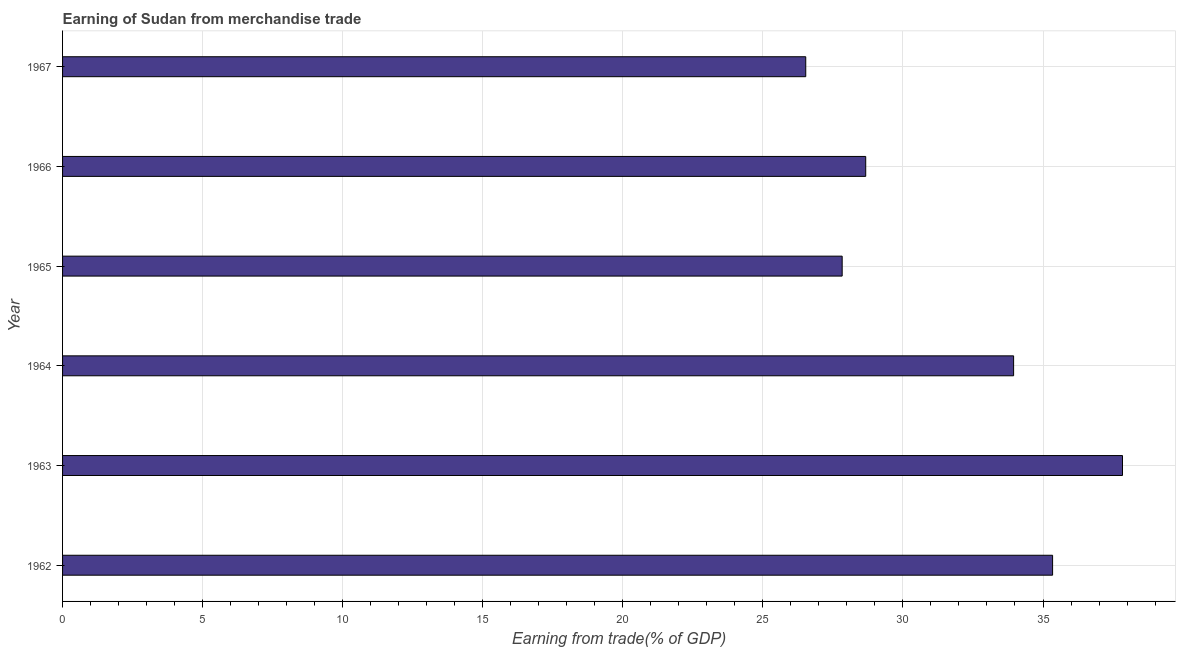What is the title of the graph?
Your answer should be compact. Earning of Sudan from merchandise trade. What is the label or title of the X-axis?
Offer a very short reply. Earning from trade(% of GDP). What is the earning from merchandise trade in 1963?
Give a very brief answer. 37.84. Across all years, what is the maximum earning from merchandise trade?
Make the answer very short. 37.84. Across all years, what is the minimum earning from merchandise trade?
Your answer should be compact. 26.53. In which year was the earning from merchandise trade minimum?
Ensure brevity in your answer.  1967. What is the sum of the earning from merchandise trade?
Ensure brevity in your answer.  190.17. What is the difference between the earning from merchandise trade in 1963 and 1965?
Keep it short and to the point. 10.01. What is the average earning from merchandise trade per year?
Your response must be concise. 31.69. What is the median earning from merchandise trade?
Offer a very short reply. 31.31. In how many years, is the earning from merchandise trade greater than 18 %?
Provide a succinct answer. 6. Do a majority of the years between 1964 and 1962 (inclusive) have earning from merchandise trade greater than 32 %?
Keep it short and to the point. Yes. What is the ratio of the earning from merchandise trade in 1965 to that in 1967?
Provide a succinct answer. 1.05. Is the earning from merchandise trade in 1965 less than that in 1966?
Offer a very short reply. Yes. Is the difference between the earning from merchandise trade in 1964 and 1967 greater than the difference between any two years?
Make the answer very short. No. What is the difference between the highest and the second highest earning from merchandise trade?
Ensure brevity in your answer.  2.5. Is the sum of the earning from merchandise trade in 1964 and 1965 greater than the maximum earning from merchandise trade across all years?
Keep it short and to the point. Yes. What is the difference between the highest and the lowest earning from merchandise trade?
Provide a succinct answer. 11.31. In how many years, is the earning from merchandise trade greater than the average earning from merchandise trade taken over all years?
Give a very brief answer. 3. What is the difference between two consecutive major ticks on the X-axis?
Make the answer very short. 5. What is the Earning from trade(% of GDP) of 1962?
Your answer should be very brief. 35.34. What is the Earning from trade(% of GDP) in 1963?
Give a very brief answer. 37.84. What is the Earning from trade(% of GDP) in 1964?
Your response must be concise. 33.95. What is the Earning from trade(% of GDP) of 1965?
Make the answer very short. 27.83. What is the Earning from trade(% of GDP) of 1966?
Your answer should be very brief. 28.67. What is the Earning from trade(% of GDP) of 1967?
Keep it short and to the point. 26.53. What is the difference between the Earning from trade(% of GDP) in 1962 and 1963?
Ensure brevity in your answer.  -2.5. What is the difference between the Earning from trade(% of GDP) in 1962 and 1964?
Your response must be concise. 1.39. What is the difference between the Earning from trade(% of GDP) in 1962 and 1965?
Provide a succinct answer. 7.51. What is the difference between the Earning from trade(% of GDP) in 1962 and 1966?
Your response must be concise. 6.67. What is the difference between the Earning from trade(% of GDP) in 1962 and 1967?
Provide a succinct answer. 8.81. What is the difference between the Earning from trade(% of GDP) in 1963 and 1964?
Offer a terse response. 3.89. What is the difference between the Earning from trade(% of GDP) in 1963 and 1965?
Your response must be concise. 10.01. What is the difference between the Earning from trade(% of GDP) in 1963 and 1966?
Give a very brief answer. 9.17. What is the difference between the Earning from trade(% of GDP) in 1963 and 1967?
Give a very brief answer. 11.31. What is the difference between the Earning from trade(% of GDP) in 1964 and 1965?
Your answer should be very brief. 6.12. What is the difference between the Earning from trade(% of GDP) in 1964 and 1966?
Your response must be concise. 5.28. What is the difference between the Earning from trade(% of GDP) in 1964 and 1967?
Offer a very short reply. 7.42. What is the difference between the Earning from trade(% of GDP) in 1965 and 1966?
Keep it short and to the point. -0.84. What is the difference between the Earning from trade(% of GDP) in 1965 and 1967?
Give a very brief answer. 1.3. What is the difference between the Earning from trade(% of GDP) in 1966 and 1967?
Provide a succinct answer. 2.14. What is the ratio of the Earning from trade(% of GDP) in 1962 to that in 1963?
Provide a succinct answer. 0.93. What is the ratio of the Earning from trade(% of GDP) in 1962 to that in 1964?
Keep it short and to the point. 1.04. What is the ratio of the Earning from trade(% of GDP) in 1962 to that in 1965?
Your answer should be very brief. 1.27. What is the ratio of the Earning from trade(% of GDP) in 1962 to that in 1966?
Your answer should be compact. 1.23. What is the ratio of the Earning from trade(% of GDP) in 1962 to that in 1967?
Make the answer very short. 1.33. What is the ratio of the Earning from trade(% of GDP) in 1963 to that in 1964?
Make the answer very short. 1.11. What is the ratio of the Earning from trade(% of GDP) in 1963 to that in 1965?
Ensure brevity in your answer.  1.36. What is the ratio of the Earning from trade(% of GDP) in 1963 to that in 1966?
Your response must be concise. 1.32. What is the ratio of the Earning from trade(% of GDP) in 1963 to that in 1967?
Ensure brevity in your answer.  1.43. What is the ratio of the Earning from trade(% of GDP) in 1964 to that in 1965?
Your answer should be compact. 1.22. What is the ratio of the Earning from trade(% of GDP) in 1964 to that in 1966?
Keep it short and to the point. 1.18. What is the ratio of the Earning from trade(% of GDP) in 1964 to that in 1967?
Your answer should be very brief. 1.28. What is the ratio of the Earning from trade(% of GDP) in 1965 to that in 1967?
Your answer should be compact. 1.05. What is the ratio of the Earning from trade(% of GDP) in 1966 to that in 1967?
Ensure brevity in your answer.  1.08. 